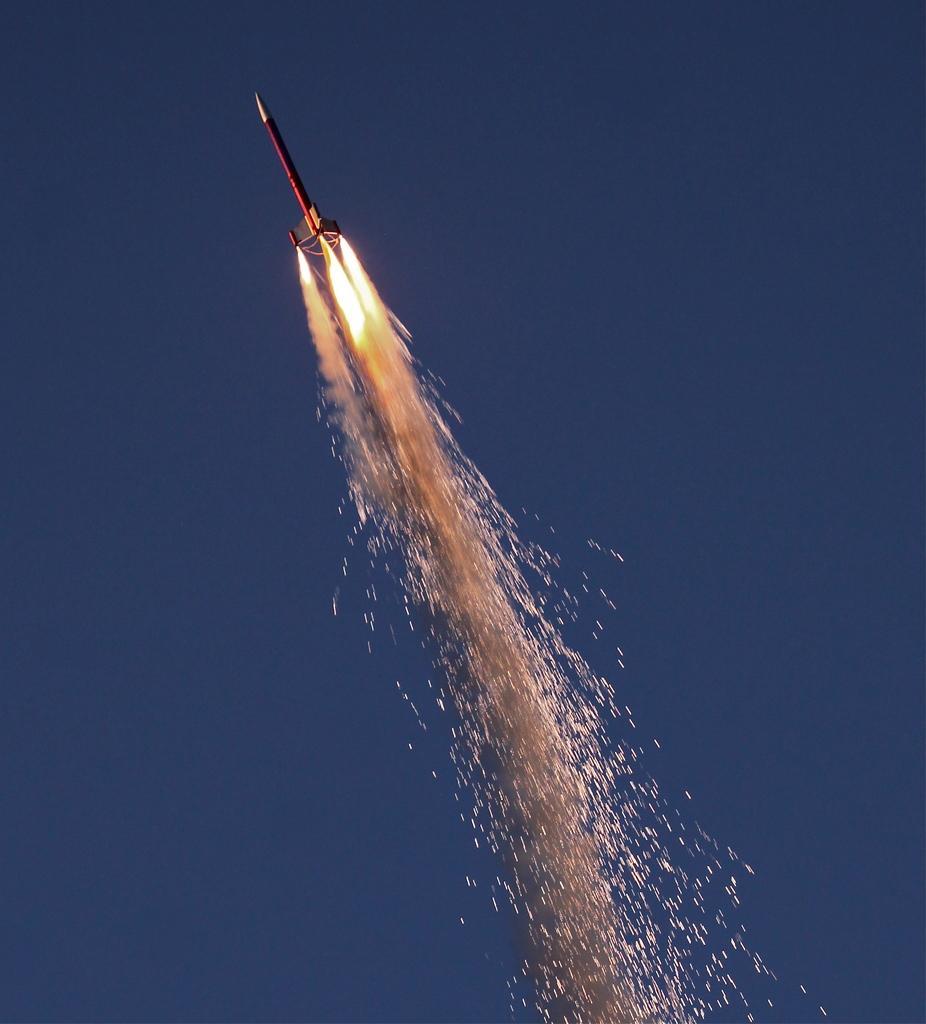In one or two sentences, can you explain what this image depicts? In this image we can see a rocket with fire flying in the sky. 